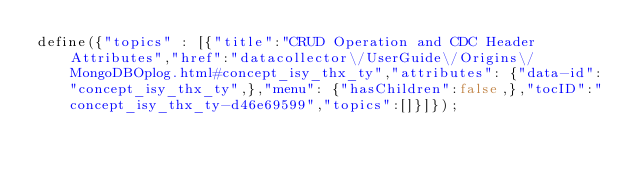Convert code to text. <code><loc_0><loc_0><loc_500><loc_500><_JavaScript_>define({"topics" : [{"title":"CRUD Operation and CDC Header Attributes","href":"datacollector\/UserGuide\/Origins\/MongoDBOplog.html#concept_isy_thx_ty","attributes": {"data-id":"concept_isy_thx_ty",},"menu": {"hasChildren":false,},"tocID":"concept_isy_thx_ty-d46e69599","topics":[]}]});</code> 